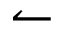Convert formula to latex. <formula><loc_0><loc_0><loc_500><loc_500>\leftharpoonup</formula> 